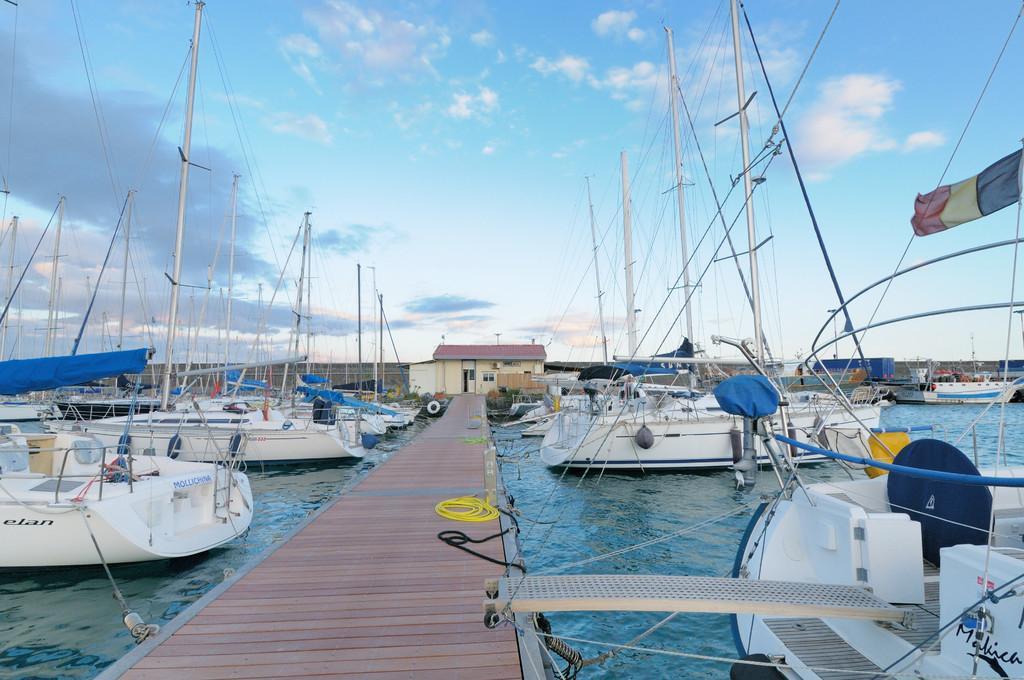In one or two sentences, can you explain what this image depicts? In this image I can see the wooden bridge on the surface of the water and I can see few boats which are white and blue in color on the surface of the water and tied to the bridge. In the background I can see few buildings and the sky. 